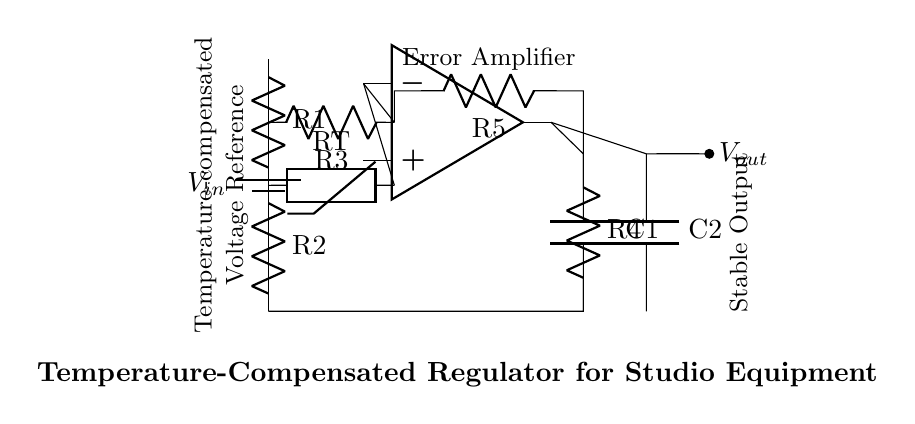What is the input voltage in the circuit? The input voltage is labeled as V_in in the circuit diagram, which denotes the voltage supplied to the regulator.
Answer: V_in What is the role of the thermistor in this circuit? The thermistor, labeled as RT, is a temperature-sensitive resistor that helps in compensating for temperature variations, affecting the output voltage and maintaining stability.
Answer: Temperature compensation How many resistors are used in the voltage divider? There are two resistors, R1 and R2, in the voltage divider configuration, which together determine the input to the operational amplifier.
Answer: Two What is the output voltage represented as in the diagram? The output voltage is denoted by V_out, which indicates the voltage that the regulator provides to the load.
Answer: V_out What is the purpose of the operational amplifier in this circuit? The operational amplifier, labeled in the diagram, functions as an error amplifier to compare the reference voltage with the output voltage and adjust it accordingly to maintain a stable output.
Answer: Error amplification What type of output do capacitors C1 and C2 provide? The capacitors C1 and C2 are used for stability in the regulator circuit, smoothing out fluctuations and helping to maintain a consistent voltage output.
Answer: Stable output What is the function of resistor R4 in this circuit? Resistor R4 is part of the feedback loop connected to the operational amplifier, which helps in stabilizing the output by setting the gain of the feedback network.
Answer: Feedback stabilization 